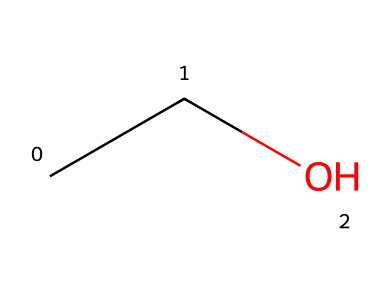What is the name of this chemical? The SMILES representation "CCO" corresponds to ethanol, which is a common volatile and flammable liquid used in alcoholic beverages.
Answer: ethanol How many carbon atoms are in this molecule? The structure shows "CCO," which indicates that there are two carbon (C) atoms present in the molecule. Each "C" represents one carbon atom, and there are two occurrences of it.
Answer: 2 What functional group is present in this molecule? The structure "CCO" indicates that this molecule contains a hydroxyl group (–OH) attached to a carbon chain, which is characteristic of alcohols. Therefore, the functional group present is hydroxyl.
Answer: hydroxyl What is the molecular formula of this compound? From the SMILES representation "CCO," there are two carbon atoms, five hydrogen atoms, and one oxygen atom. Combining these, the molecular formula is C2H6O.
Answer: C2H6O Is this compound polar or non-polar? The presence of the hydroxyl group (–OH) in "CCO" makes this compound polar due to the difference in electronegativity between oxygen and hydrogen, causing a dipole moment.
Answer: polar What type of alcohol is ethanol? Since ethanol has the structure of a simple alcohol with two carbon atoms and one hydroxyl group, it is classified as a primary alcohol, meaning the carbon attached to the hydroxyl group is only connected to one other carbon.
Answer: primary 